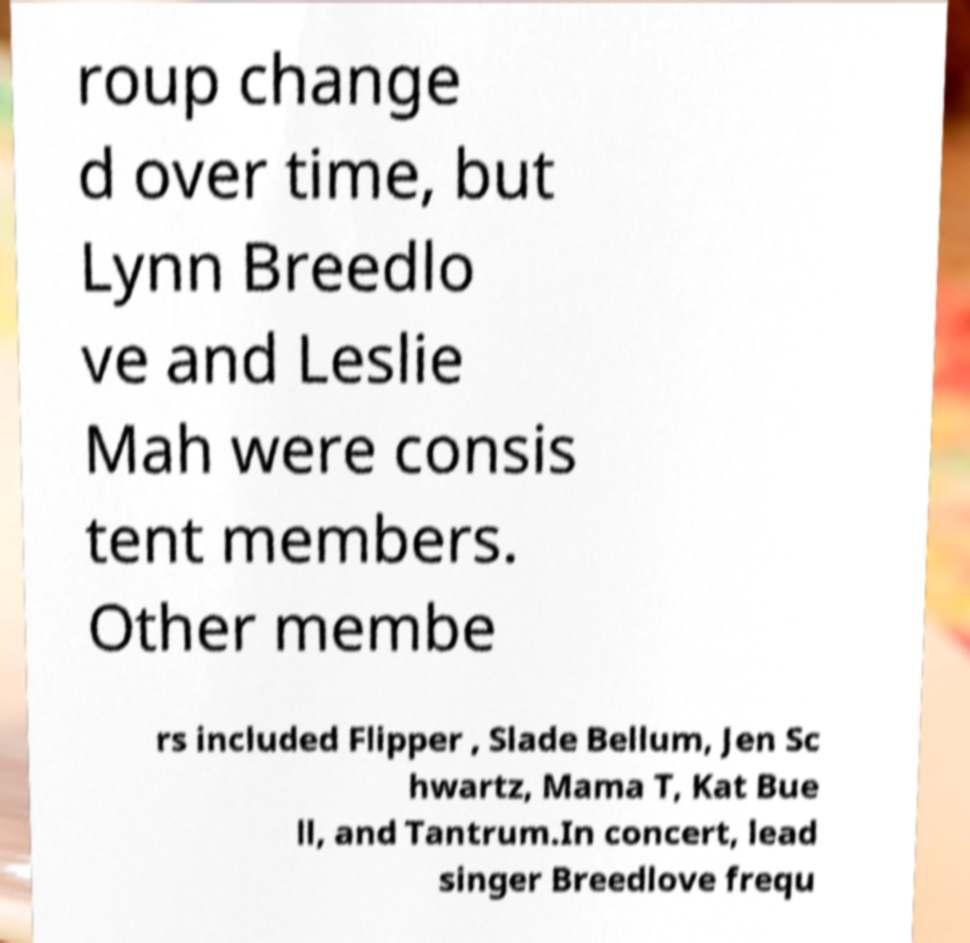There's text embedded in this image that I need extracted. Can you transcribe it verbatim? roup change d over time, but Lynn Breedlo ve and Leslie Mah were consis tent members. Other membe rs included Flipper , Slade Bellum, Jen Sc hwartz, Mama T, Kat Bue ll, and Tantrum.In concert, lead singer Breedlove frequ 